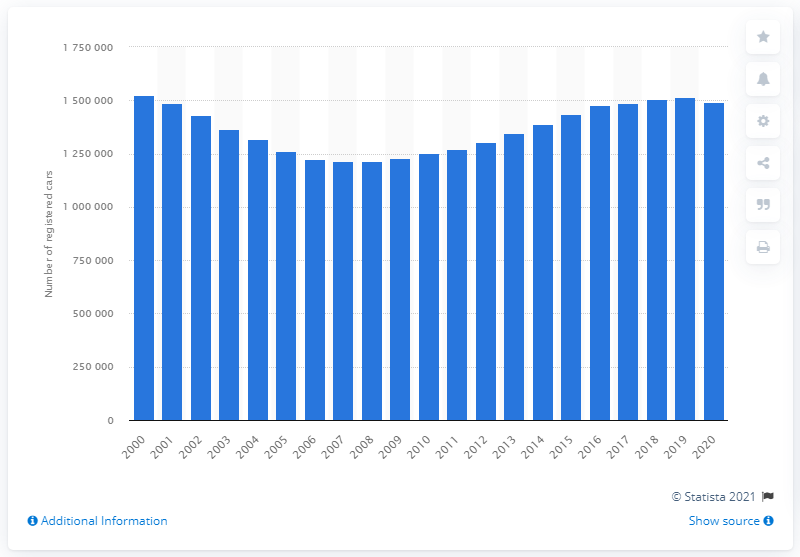Identify some key points in this picture. By the end of 2020, there were a total of 149,144,305 Ford Fiesta cars that had been registered and driven on the roads of Great Britain. The number of Ford Fiesta registered cars increased steadily in the year 2008. 